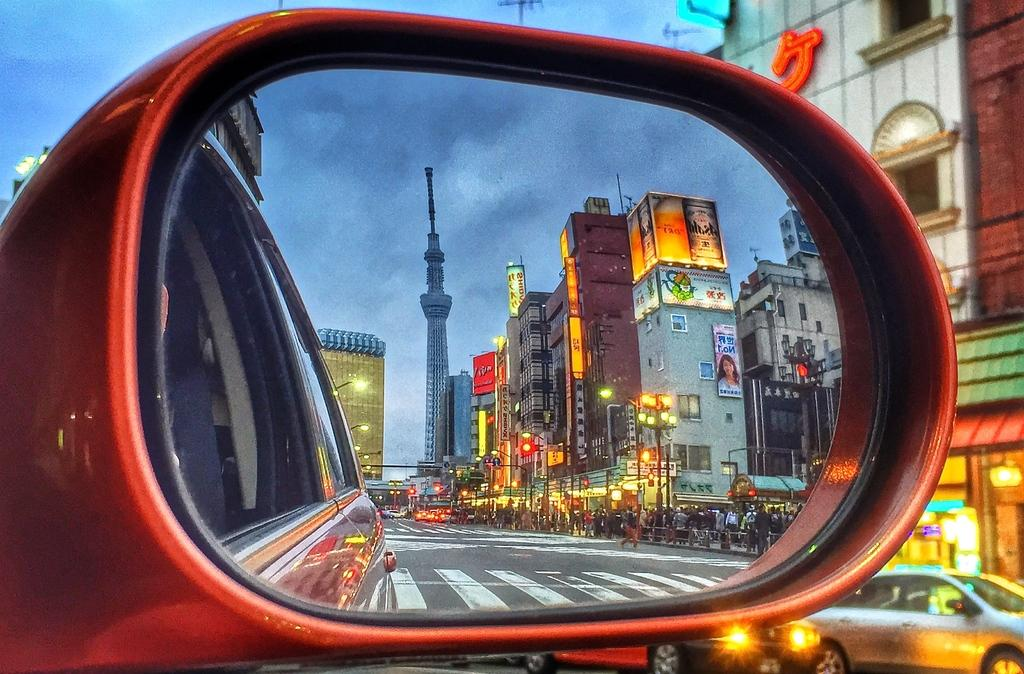What type of view is shown in the image? The image shows a street view of a city. From where is the view captured? The view is through the rear view mirror of a car. What else can be seen in the image besides the city view? Other cars are visible in the image. What is visible in the background of the image? Buildings are present in the background of the image. What type of lights are visible in the image? There are lights visible in the image. What type of popcorn is being served in the image? There is no popcorn present in the image; it shows a street view through a car's rear view mirror. 